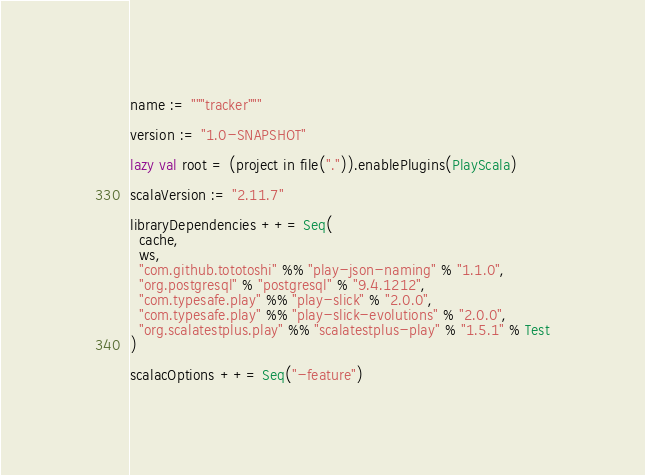Convert code to text. <code><loc_0><loc_0><loc_500><loc_500><_Scala_>name := """tracker"""

version := "1.0-SNAPSHOT"

lazy val root = (project in file(".")).enablePlugins(PlayScala)

scalaVersion := "2.11.7"

libraryDependencies ++= Seq(
  cache,
  ws,
  "com.github.tototoshi" %% "play-json-naming" % "1.1.0",
  "org.postgresql" % "postgresql" % "9.4.1212",
  "com.typesafe.play" %% "play-slick" % "2.0.0",
  "com.typesafe.play" %% "play-slick-evolutions" % "2.0.0",
  "org.scalatestplus.play" %% "scalatestplus-play" % "1.5.1" % Test
)

scalacOptions ++= Seq("-feature")
</code> 